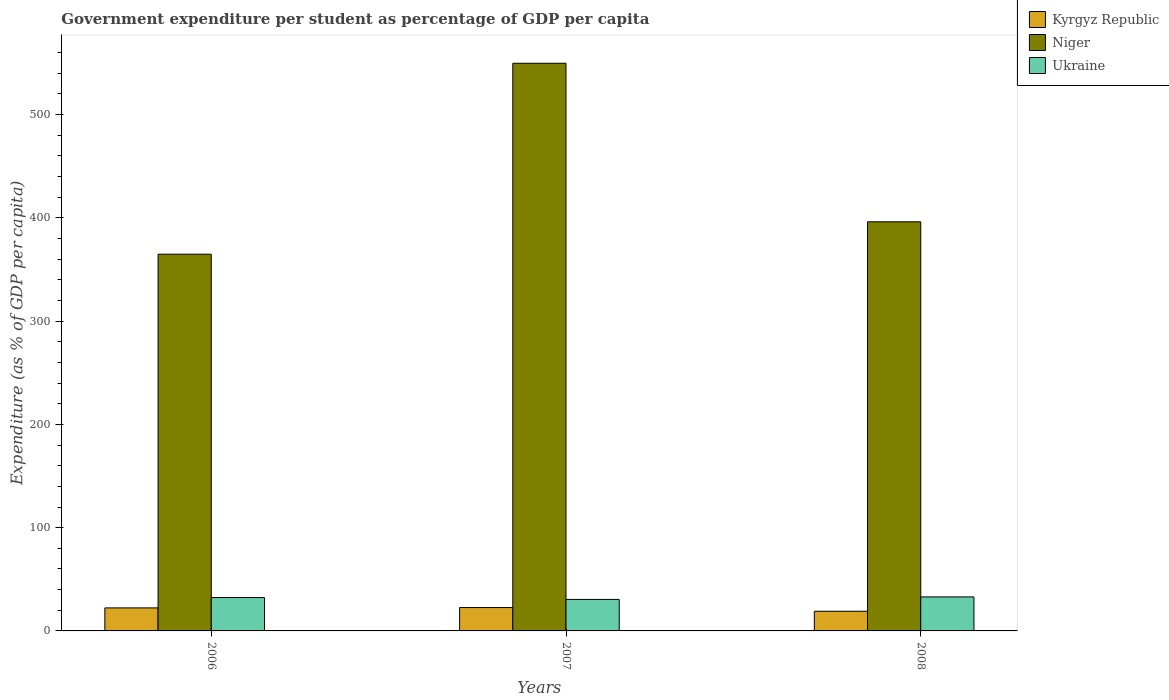How many groups of bars are there?
Provide a succinct answer. 3. Are the number of bars on each tick of the X-axis equal?
Provide a succinct answer. Yes. What is the label of the 3rd group of bars from the left?
Offer a terse response. 2008. What is the percentage of expenditure per student in Kyrgyz Republic in 2007?
Keep it short and to the point. 22.64. Across all years, what is the maximum percentage of expenditure per student in Kyrgyz Republic?
Provide a succinct answer. 22.64. Across all years, what is the minimum percentage of expenditure per student in Kyrgyz Republic?
Provide a short and direct response. 19.04. In which year was the percentage of expenditure per student in Niger minimum?
Make the answer very short. 2006. What is the total percentage of expenditure per student in Niger in the graph?
Ensure brevity in your answer.  1310.78. What is the difference between the percentage of expenditure per student in Kyrgyz Republic in 2006 and that in 2007?
Provide a succinct answer. -0.34. What is the difference between the percentage of expenditure per student in Ukraine in 2007 and the percentage of expenditure per student in Kyrgyz Republic in 2006?
Keep it short and to the point. 8.22. What is the average percentage of expenditure per student in Kyrgyz Republic per year?
Keep it short and to the point. 21.33. In the year 2007, what is the difference between the percentage of expenditure per student in Kyrgyz Republic and percentage of expenditure per student in Ukraine?
Ensure brevity in your answer.  -7.88. What is the ratio of the percentage of expenditure per student in Ukraine in 2007 to that in 2008?
Make the answer very short. 0.93. What is the difference between the highest and the second highest percentage of expenditure per student in Kyrgyz Republic?
Your response must be concise. 0.34. What is the difference between the highest and the lowest percentage of expenditure per student in Niger?
Your answer should be very brief. 184.9. Is the sum of the percentage of expenditure per student in Niger in 2006 and 2008 greater than the maximum percentage of expenditure per student in Ukraine across all years?
Offer a terse response. Yes. What does the 1st bar from the left in 2007 represents?
Give a very brief answer. Kyrgyz Republic. What does the 1st bar from the right in 2007 represents?
Ensure brevity in your answer.  Ukraine. Is it the case that in every year, the sum of the percentage of expenditure per student in Kyrgyz Republic and percentage of expenditure per student in Ukraine is greater than the percentage of expenditure per student in Niger?
Provide a short and direct response. No. Are all the bars in the graph horizontal?
Your answer should be very brief. No. Does the graph contain any zero values?
Offer a very short reply. No. Does the graph contain grids?
Offer a very short reply. No. What is the title of the graph?
Your answer should be very brief. Government expenditure per student as percentage of GDP per capita. Does "Lithuania" appear as one of the legend labels in the graph?
Make the answer very short. No. What is the label or title of the Y-axis?
Provide a succinct answer. Expenditure (as % of GDP per capita). What is the Expenditure (as % of GDP per capita) of Kyrgyz Republic in 2006?
Keep it short and to the point. 22.3. What is the Expenditure (as % of GDP per capita) in Niger in 2006?
Give a very brief answer. 364.84. What is the Expenditure (as % of GDP per capita) of Ukraine in 2006?
Your answer should be very brief. 32.32. What is the Expenditure (as % of GDP per capita) of Kyrgyz Republic in 2007?
Give a very brief answer. 22.64. What is the Expenditure (as % of GDP per capita) in Niger in 2007?
Ensure brevity in your answer.  549.74. What is the Expenditure (as % of GDP per capita) in Ukraine in 2007?
Give a very brief answer. 30.52. What is the Expenditure (as % of GDP per capita) in Kyrgyz Republic in 2008?
Your answer should be very brief. 19.04. What is the Expenditure (as % of GDP per capita) of Niger in 2008?
Ensure brevity in your answer.  396.2. What is the Expenditure (as % of GDP per capita) of Ukraine in 2008?
Your answer should be compact. 32.93. Across all years, what is the maximum Expenditure (as % of GDP per capita) of Kyrgyz Republic?
Your answer should be very brief. 22.64. Across all years, what is the maximum Expenditure (as % of GDP per capita) of Niger?
Give a very brief answer. 549.74. Across all years, what is the maximum Expenditure (as % of GDP per capita) in Ukraine?
Make the answer very short. 32.93. Across all years, what is the minimum Expenditure (as % of GDP per capita) of Kyrgyz Republic?
Your answer should be compact. 19.04. Across all years, what is the minimum Expenditure (as % of GDP per capita) of Niger?
Offer a very short reply. 364.84. Across all years, what is the minimum Expenditure (as % of GDP per capita) in Ukraine?
Provide a succinct answer. 30.52. What is the total Expenditure (as % of GDP per capita) of Kyrgyz Republic in the graph?
Provide a short and direct response. 63.98. What is the total Expenditure (as % of GDP per capita) in Niger in the graph?
Ensure brevity in your answer.  1310.78. What is the total Expenditure (as % of GDP per capita) of Ukraine in the graph?
Keep it short and to the point. 95.77. What is the difference between the Expenditure (as % of GDP per capita) of Kyrgyz Republic in 2006 and that in 2007?
Provide a short and direct response. -0.34. What is the difference between the Expenditure (as % of GDP per capita) of Niger in 2006 and that in 2007?
Offer a terse response. -184.9. What is the difference between the Expenditure (as % of GDP per capita) in Ukraine in 2006 and that in 2007?
Provide a short and direct response. 1.8. What is the difference between the Expenditure (as % of GDP per capita) in Kyrgyz Republic in 2006 and that in 2008?
Your answer should be very brief. 3.26. What is the difference between the Expenditure (as % of GDP per capita) of Niger in 2006 and that in 2008?
Offer a very short reply. -31.37. What is the difference between the Expenditure (as % of GDP per capita) of Ukraine in 2006 and that in 2008?
Your response must be concise. -0.61. What is the difference between the Expenditure (as % of GDP per capita) of Kyrgyz Republic in 2007 and that in 2008?
Make the answer very short. 3.59. What is the difference between the Expenditure (as % of GDP per capita) in Niger in 2007 and that in 2008?
Offer a terse response. 153.53. What is the difference between the Expenditure (as % of GDP per capita) in Ukraine in 2007 and that in 2008?
Your answer should be very brief. -2.42. What is the difference between the Expenditure (as % of GDP per capita) in Kyrgyz Republic in 2006 and the Expenditure (as % of GDP per capita) in Niger in 2007?
Your answer should be compact. -527.44. What is the difference between the Expenditure (as % of GDP per capita) in Kyrgyz Republic in 2006 and the Expenditure (as % of GDP per capita) in Ukraine in 2007?
Ensure brevity in your answer.  -8.22. What is the difference between the Expenditure (as % of GDP per capita) of Niger in 2006 and the Expenditure (as % of GDP per capita) of Ukraine in 2007?
Offer a very short reply. 334.32. What is the difference between the Expenditure (as % of GDP per capita) of Kyrgyz Republic in 2006 and the Expenditure (as % of GDP per capita) of Niger in 2008?
Your response must be concise. -373.91. What is the difference between the Expenditure (as % of GDP per capita) of Kyrgyz Republic in 2006 and the Expenditure (as % of GDP per capita) of Ukraine in 2008?
Your answer should be very brief. -10.64. What is the difference between the Expenditure (as % of GDP per capita) of Niger in 2006 and the Expenditure (as % of GDP per capita) of Ukraine in 2008?
Keep it short and to the point. 331.9. What is the difference between the Expenditure (as % of GDP per capita) in Kyrgyz Republic in 2007 and the Expenditure (as % of GDP per capita) in Niger in 2008?
Keep it short and to the point. -373.57. What is the difference between the Expenditure (as % of GDP per capita) in Kyrgyz Republic in 2007 and the Expenditure (as % of GDP per capita) in Ukraine in 2008?
Give a very brief answer. -10.3. What is the difference between the Expenditure (as % of GDP per capita) in Niger in 2007 and the Expenditure (as % of GDP per capita) in Ukraine in 2008?
Provide a succinct answer. 516.81. What is the average Expenditure (as % of GDP per capita) in Kyrgyz Republic per year?
Give a very brief answer. 21.33. What is the average Expenditure (as % of GDP per capita) in Niger per year?
Your answer should be very brief. 436.93. What is the average Expenditure (as % of GDP per capita) in Ukraine per year?
Give a very brief answer. 31.92. In the year 2006, what is the difference between the Expenditure (as % of GDP per capita) in Kyrgyz Republic and Expenditure (as % of GDP per capita) in Niger?
Provide a succinct answer. -342.54. In the year 2006, what is the difference between the Expenditure (as % of GDP per capita) of Kyrgyz Republic and Expenditure (as % of GDP per capita) of Ukraine?
Keep it short and to the point. -10.02. In the year 2006, what is the difference between the Expenditure (as % of GDP per capita) in Niger and Expenditure (as % of GDP per capita) in Ukraine?
Your answer should be very brief. 332.51. In the year 2007, what is the difference between the Expenditure (as % of GDP per capita) of Kyrgyz Republic and Expenditure (as % of GDP per capita) of Niger?
Provide a succinct answer. -527.1. In the year 2007, what is the difference between the Expenditure (as % of GDP per capita) of Kyrgyz Republic and Expenditure (as % of GDP per capita) of Ukraine?
Your response must be concise. -7.88. In the year 2007, what is the difference between the Expenditure (as % of GDP per capita) in Niger and Expenditure (as % of GDP per capita) in Ukraine?
Provide a short and direct response. 519.22. In the year 2008, what is the difference between the Expenditure (as % of GDP per capita) in Kyrgyz Republic and Expenditure (as % of GDP per capita) in Niger?
Offer a very short reply. -377.16. In the year 2008, what is the difference between the Expenditure (as % of GDP per capita) in Kyrgyz Republic and Expenditure (as % of GDP per capita) in Ukraine?
Keep it short and to the point. -13.89. In the year 2008, what is the difference between the Expenditure (as % of GDP per capita) of Niger and Expenditure (as % of GDP per capita) of Ukraine?
Make the answer very short. 363.27. What is the ratio of the Expenditure (as % of GDP per capita) of Kyrgyz Republic in 2006 to that in 2007?
Offer a terse response. 0.99. What is the ratio of the Expenditure (as % of GDP per capita) in Niger in 2006 to that in 2007?
Your answer should be very brief. 0.66. What is the ratio of the Expenditure (as % of GDP per capita) in Ukraine in 2006 to that in 2007?
Your response must be concise. 1.06. What is the ratio of the Expenditure (as % of GDP per capita) of Kyrgyz Republic in 2006 to that in 2008?
Provide a succinct answer. 1.17. What is the ratio of the Expenditure (as % of GDP per capita) in Niger in 2006 to that in 2008?
Give a very brief answer. 0.92. What is the ratio of the Expenditure (as % of GDP per capita) of Ukraine in 2006 to that in 2008?
Provide a succinct answer. 0.98. What is the ratio of the Expenditure (as % of GDP per capita) in Kyrgyz Republic in 2007 to that in 2008?
Your response must be concise. 1.19. What is the ratio of the Expenditure (as % of GDP per capita) in Niger in 2007 to that in 2008?
Your answer should be very brief. 1.39. What is the ratio of the Expenditure (as % of GDP per capita) of Ukraine in 2007 to that in 2008?
Provide a succinct answer. 0.93. What is the difference between the highest and the second highest Expenditure (as % of GDP per capita) in Kyrgyz Republic?
Your response must be concise. 0.34. What is the difference between the highest and the second highest Expenditure (as % of GDP per capita) in Niger?
Give a very brief answer. 153.53. What is the difference between the highest and the second highest Expenditure (as % of GDP per capita) of Ukraine?
Your answer should be compact. 0.61. What is the difference between the highest and the lowest Expenditure (as % of GDP per capita) in Kyrgyz Republic?
Ensure brevity in your answer.  3.59. What is the difference between the highest and the lowest Expenditure (as % of GDP per capita) of Niger?
Ensure brevity in your answer.  184.9. What is the difference between the highest and the lowest Expenditure (as % of GDP per capita) in Ukraine?
Give a very brief answer. 2.42. 